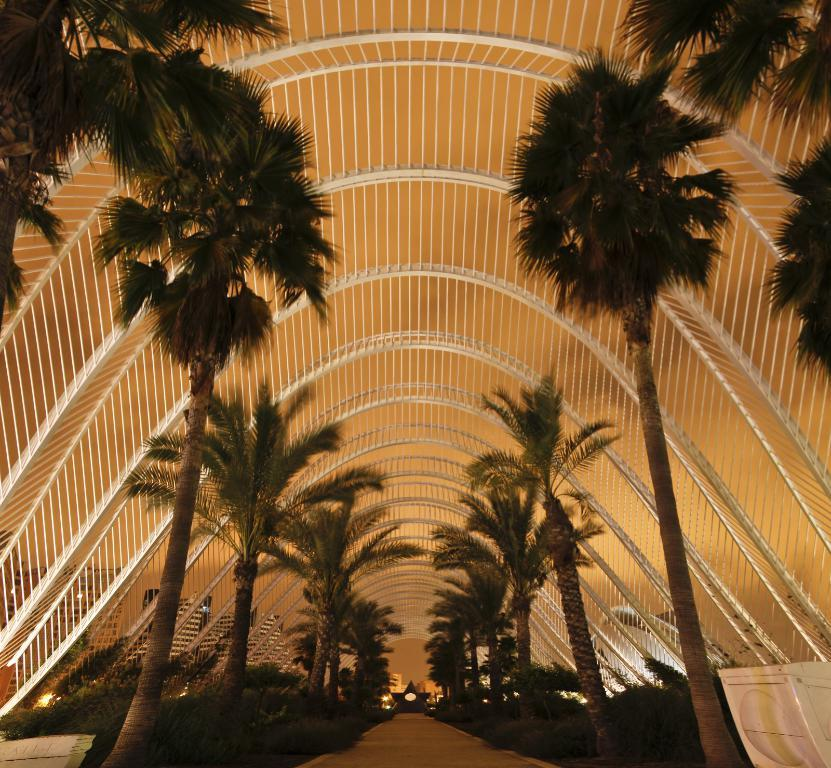What type of structure can be seen in the image? There is an arch in the image. What else is present in the image besides the arch? There are buildings, plants, trees, and the sky visible in the image. Can you describe the vegetation in the image? There are plants and trees in the image. What type of lamp is being used for arithmetic in the image? There is no lamp or arithmetic activity present in the image. 